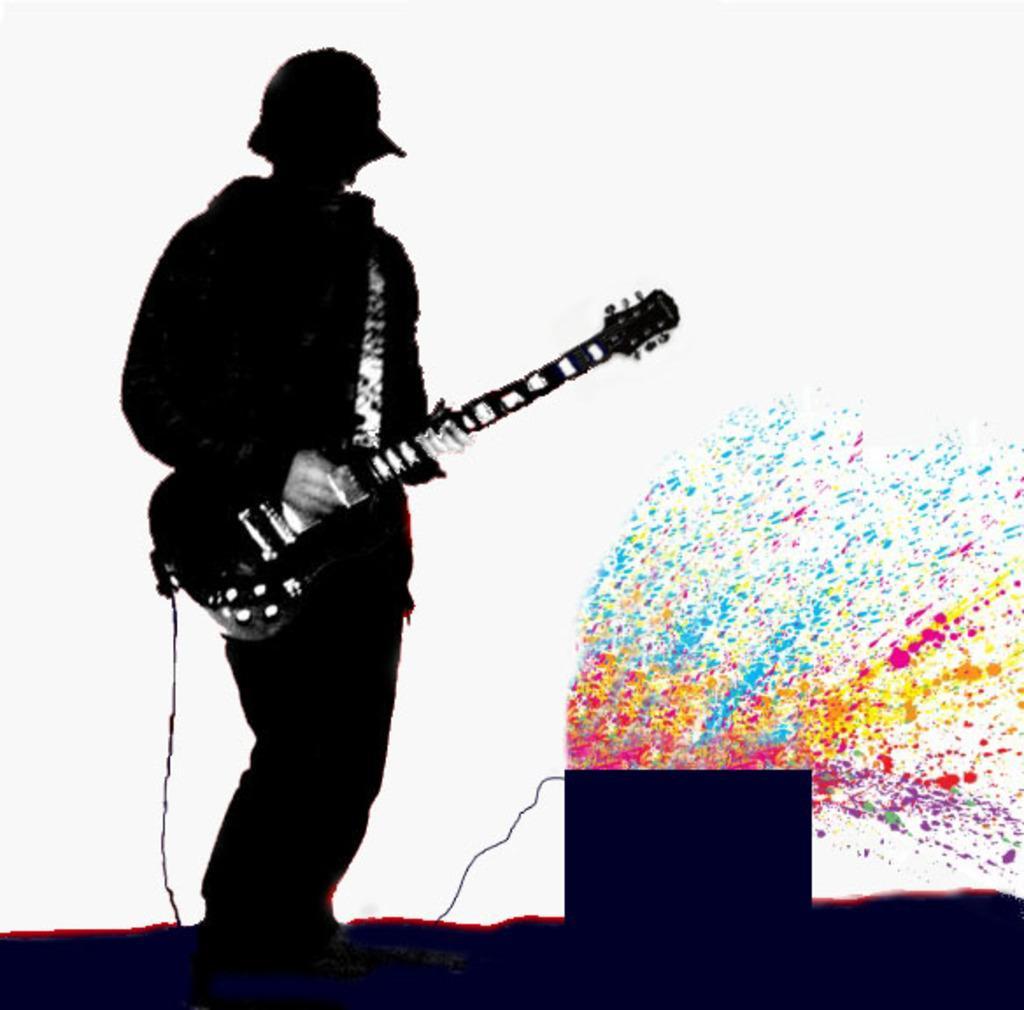Please provide a concise description of this image. As we can see in the image there is a man holding guitar. 